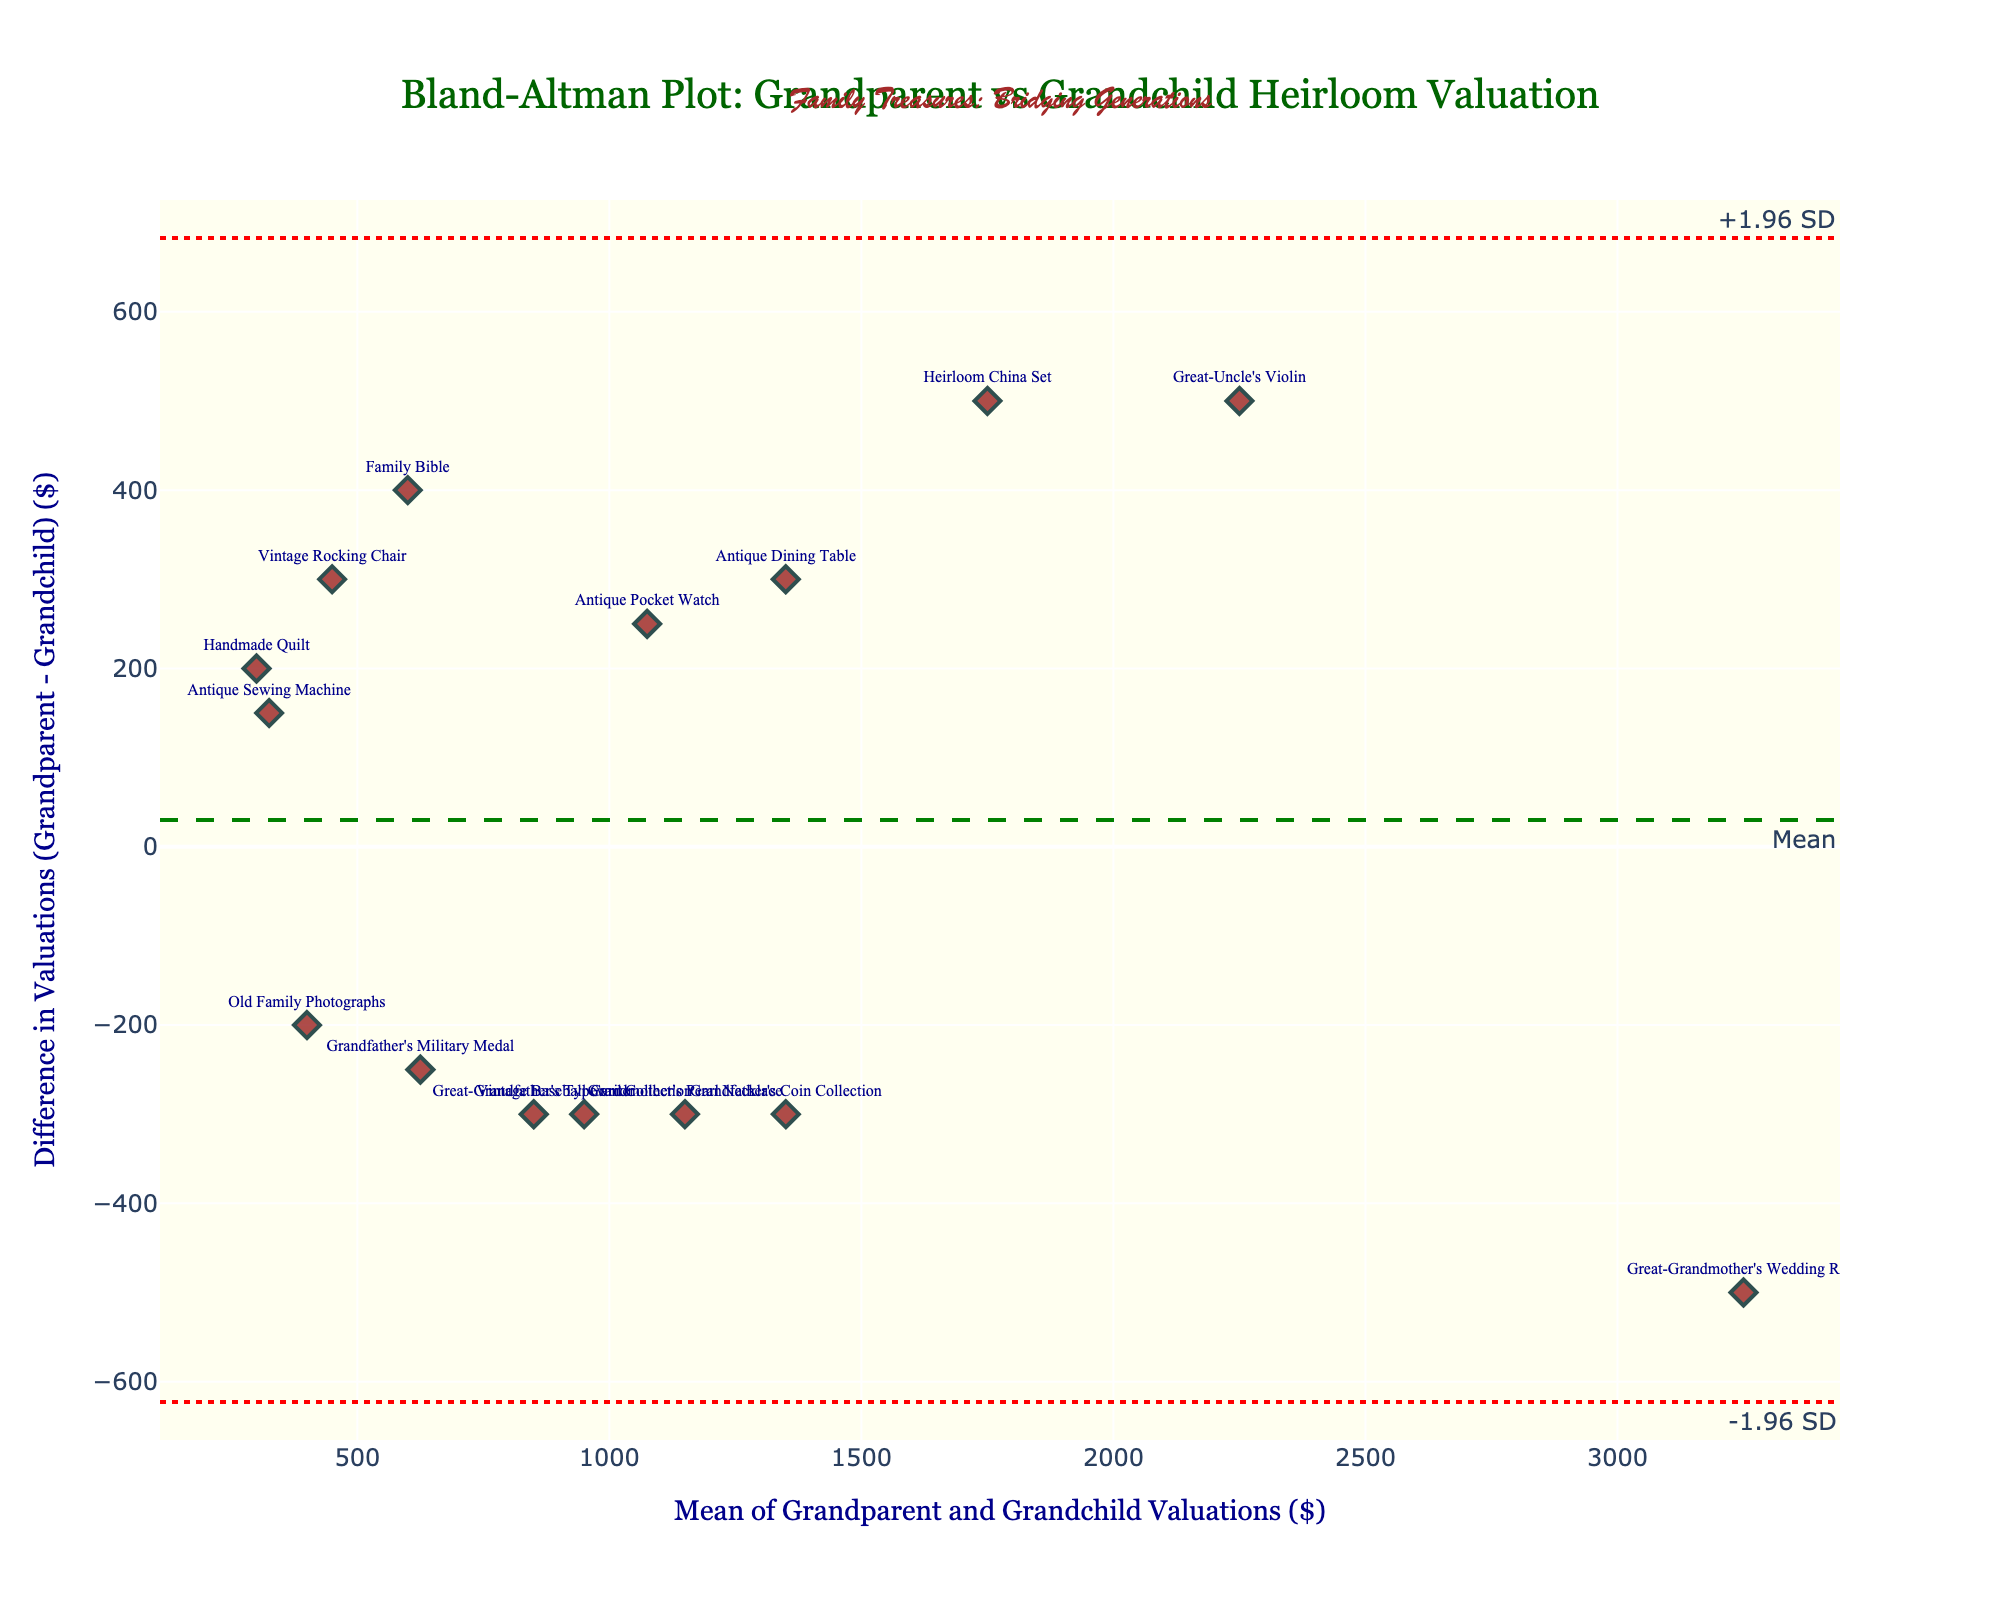How many heirlooms were assessed in the figure? The plot has 15 data points, one for each heirloom listed in the dataset with names displayed next to markers.
Answer: 15 What is the title of the plot? The title is displayed at the top of the plot in a larger font and green color.
Answer: Bland-Altman Plot: Grandparent vs Grandchild Heirloom Valuation Which heirloom shows the largest difference in valuations and how much is that difference? Look for the data point with the highest or lowest vertical position. The "Family Bible" has the largest negative difference.
Answer: Family Bible, $400 What does the green dashed line represent? The green dashed line is labeled "Mean" representing the mean of the differences between the grandparent and grandchild valuations.
Answer: Mean of differences What are the values of +1.96 SD and -1.96 SD limits? The horizontal dotted red lines are labeled, one with +1.96 SD and the other with -1.96 SD. Estimate these values based on their placement on the y-axis.
Answer: Approximately +$520 and -$860 Which heirloom's valuation by the grandchild is closest to the grandparent's valuation? Look for the data point closest to the horizontal dashed line (mean difference). The "Great-Grandmother's Wedding Ring" and "Great-Uncle's Violin" are closest.
Answer: Great-Grandmother's Wedding Ring, Great-Uncle's Violin What is the color of the points representing the heirlooms? The points are depicted in reddish color specified in the plot's marker settings.
Answer: Reddish (dark red) What does the text at the very top of the plot say? There is additional text added for a sentimental touch at the very top of the plot.
Answer: Family Treasures: Bridging Generations Which heirloom has the highest mean valuation between grandparent and grandchild? Calculate the average for each heirloom and identify the highest. The "Great-Grandmother's Wedding Ring" has the highest mean.
Answer: Great-Grandmother's Wedding Ring Are there more points above or below the mean difference line? Visually inspect if more heirlooms are above or below the green dashed line.
Answer: Below 